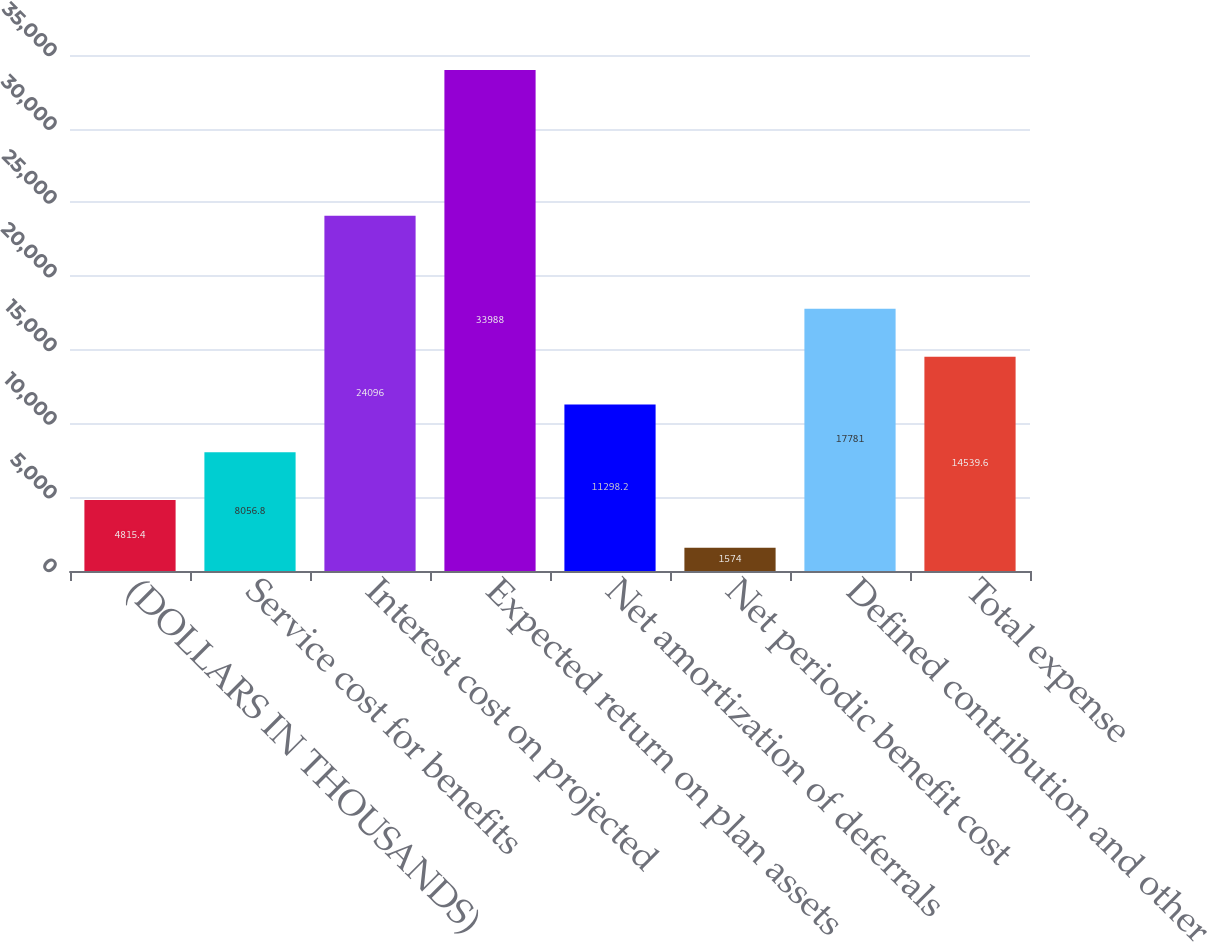Convert chart. <chart><loc_0><loc_0><loc_500><loc_500><bar_chart><fcel>(DOLLARS IN THOUSANDS)<fcel>Service cost for benefits<fcel>Interest cost on projected<fcel>Expected return on plan assets<fcel>Net amortization of deferrals<fcel>Net periodic benefit cost<fcel>Defined contribution and other<fcel>Total expense<nl><fcel>4815.4<fcel>8056.8<fcel>24096<fcel>33988<fcel>11298.2<fcel>1574<fcel>17781<fcel>14539.6<nl></chart> 